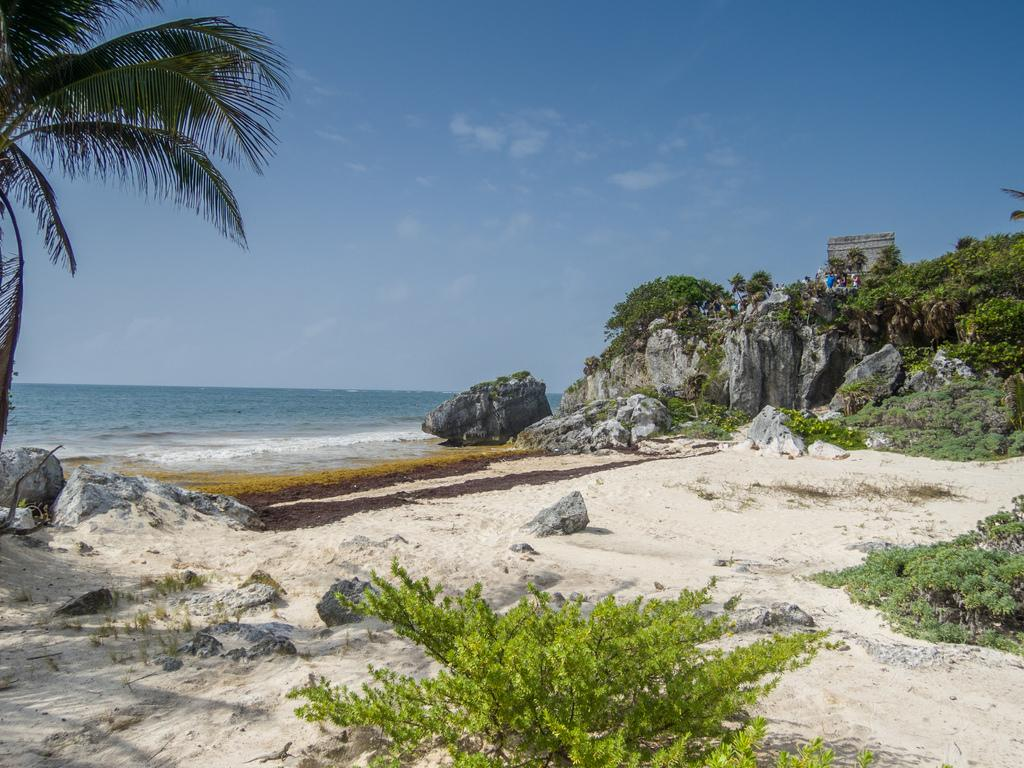What type of vegetation is present on the front side of the image? There are plants on the front side of the image. What can be seen on the left side of the image? There are tree leaves on the left side of the image. What type of natural elements are visible in the background of the image? There are rocks, water, and plants visible in the background of the image. What part of the natural environment is visible in the background of the image? The sky is visible in the background of the image. What is the distribution of the team in the image? There is no team present in the image; it features plants, tree leaves, rocks, water, and the sky. How does the roll of the plants affect the image? There is no roll of the plants mentioned in the image; the plants are stationary. 